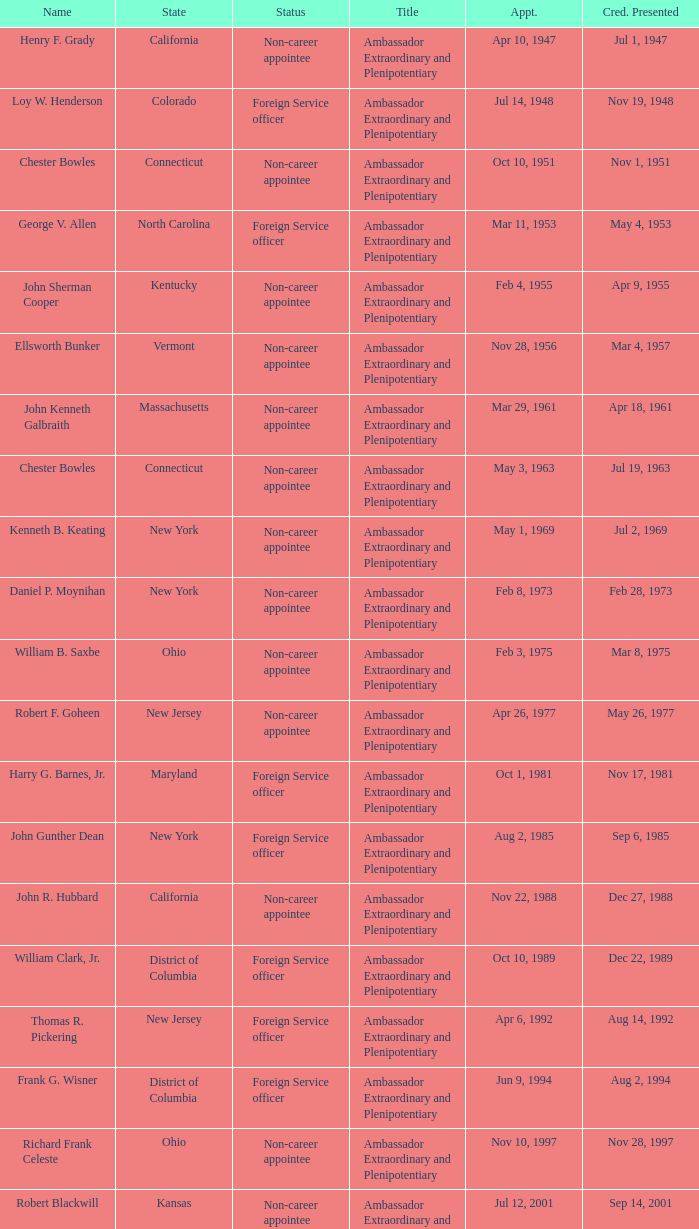When were the credentials presented for new jersey with a status of foreign service officer? Aug 14, 1992. 